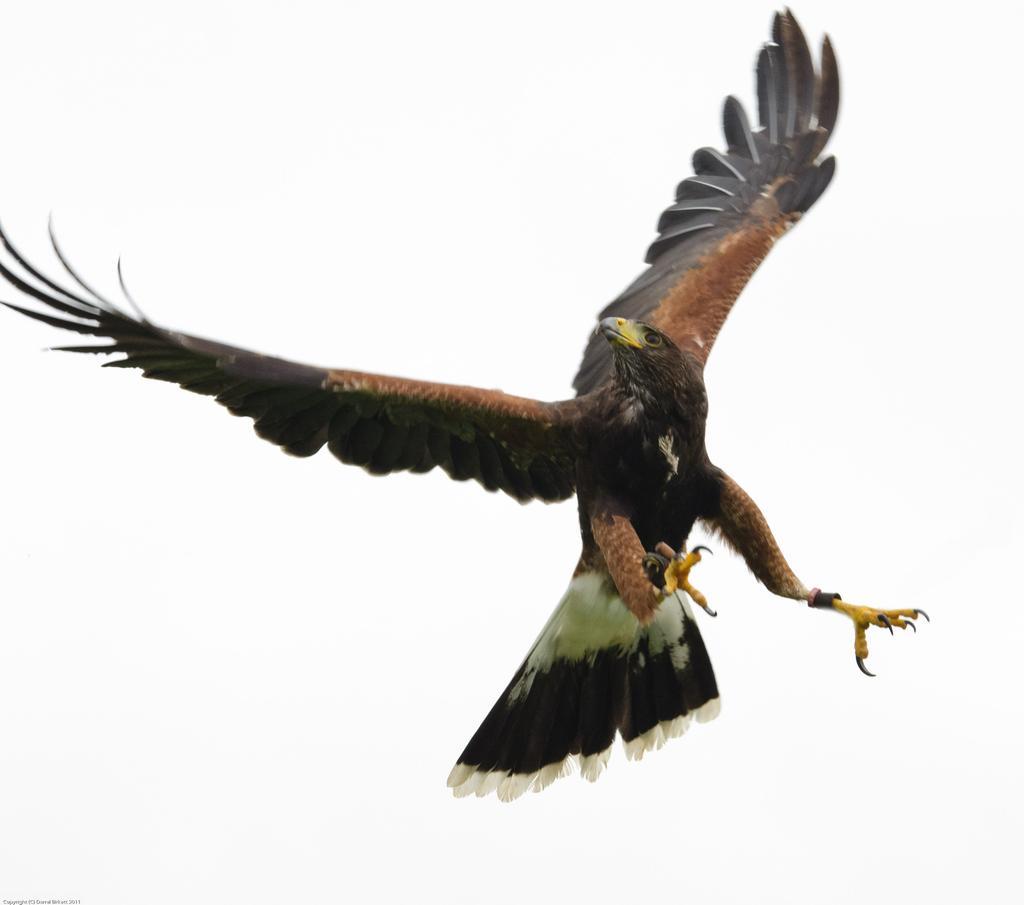In one or two sentences, can you explain what this image depicts? There is a bird flying in the air. And the background is white in color. 